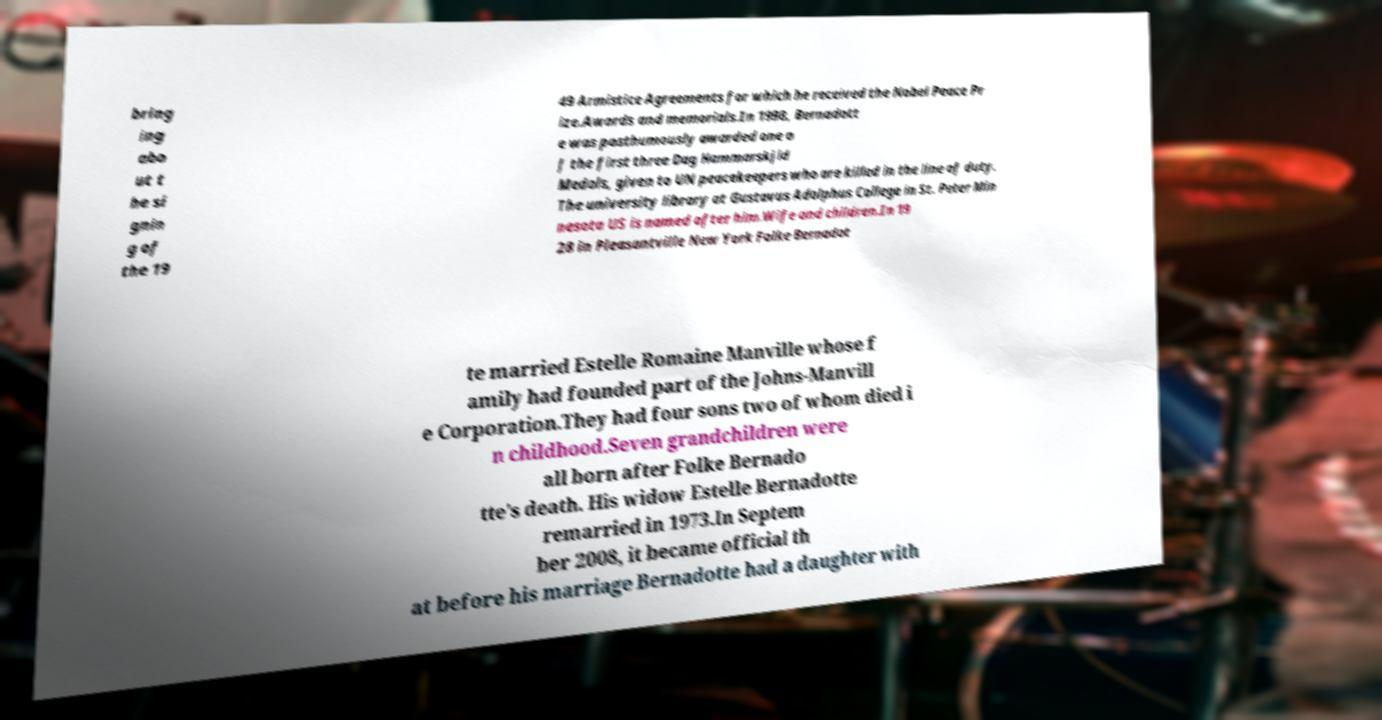Please read and relay the text visible in this image. What does it say? bring ing abo ut t he si gnin g of the 19 49 Armistice Agreements for which he received the Nobel Peace Pr ize.Awards and memorials.In 1998, Bernadott e was posthumously awarded one o f the first three Dag Hammarskjld Medals, given to UN peacekeepers who are killed in the line of duty. The university library at Gustavus Adolphus College in St. Peter Min nesota US is named after him.Wife and children.In 19 28 in Pleasantville New York Folke Bernadot te married Estelle Romaine Manville whose f amily had founded part of the Johns-Manvill e Corporation.They had four sons two of whom died i n childhood.Seven grandchildren were all born after Folke Bernado tte's death. His widow Estelle Bernadotte remarried in 1973.In Septem ber 2008, it became official th at before his marriage Bernadotte had a daughter with 